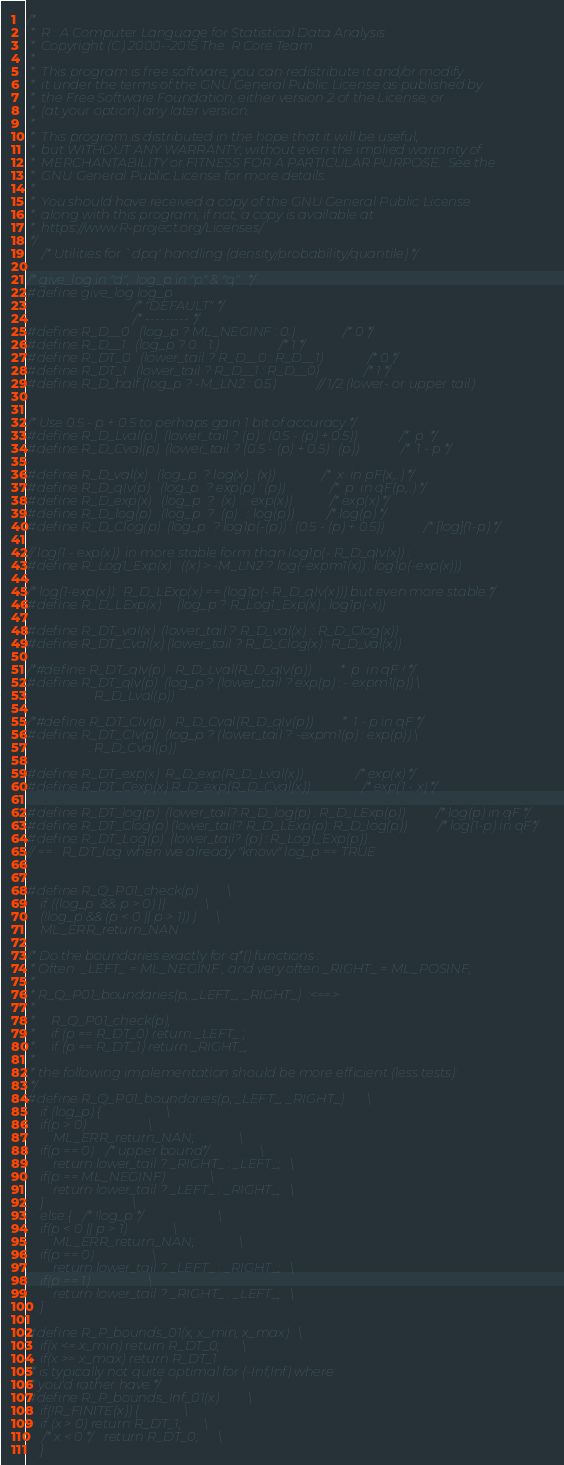<code> <loc_0><loc_0><loc_500><loc_500><_C_>/*
 *  R : A Computer Language for Statistical Data Analysis
 *  Copyright (C) 2000--2015 The  R Core Team
 *
 *  This program is free software; you can redistribute it and/or modify
 *  it under the terms of the GNU General Public License as published by
 *  the Free Software Foundation; either version 2 of the License, or
 *  (at your option) any later version.
 *
 *  This program is distributed in the hope that it will be useful,
 *  but WITHOUT ANY WARRANTY; without even the implied warranty of
 *  MERCHANTABILITY or FITNESS FOR A PARTICULAR PURPOSE.  See the
 *  GNU General Public License for more details.
 *
 *  You should have received a copy of the GNU General Public License
 *  along with this program; if not, a copy is available at
 *  https://www.R-project.org/Licenses/
 */
	/* Utilities for `dpq' handling (density/probability/quantile) */

/* give_log in "d";  log_p in "p" & "q" : */
#define give_log log_p
							/* "DEFAULT" */
							/* --------- */
#define R_D__0	(log_p ? ML_NEGINF : 0.)		/* 0 */
#define R_D__1	(log_p ? 0. : 1.)			/* 1 */
#define R_DT_0	(lower_tail ? R_D__0 : R_D__1)		/* 0 */
#define R_DT_1	(lower_tail ? R_D__1 : R_D__0)		/* 1 */
#define R_D_half (log_p ? -M_LN2 : 0.5)		// 1/2 (lower- or upper tail)


/* Use 0.5 - p + 0.5 to perhaps gain 1 bit of accuracy */
#define R_D_Lval(p)	(lower_tail ? (p) : (0.5 - (p) + 0.5))	/*  p  */
#define R_D_Cval(p)	(lower_tail ? (0.5 - (p) + 0.5) : (p))	/*  1 - p */

#define R_D_val(x)	(log_p	? log(x) : (x))		/*  x  in pF(x,..) */
#define R_D_qIv(p)	(log_p	? exp(p) : (p))		/*  p  in qF(p,..) */
#define R_D_exp(x)	(log_p	?  (x)	 : exp(x))	/* exp(x) */
#define R_D_log(p)	(log_p	?  (p)	 : log(p))	/* log(p) */
#define R_D_Clog(p)	(log_p	? log1p(-(p)) : (0.5 - (p) + 0.5)) /* [log](1-p) */

// log(1 - exp(x))  in more stable form than log1p(- R_D_qIv(x)) :
#define R_Log1_Exp(x)   ((x) > -M_LN2 ? log(-expm1(x)) : log1p(-exp(x)))

/* log(1-exp(x)):  R_D_LExp(x) == (log1p(- R_D_qIv(x))) but even more stable:*/
#define R_D_LExp(x)     (log_p ? R_Log1_Exp(x) : log1p(-x))

#define R_DT_val(x)	(lower_tail ? R_D_val(x)  : R_D_Clog(x))
#define R_DT_Cval(x)	(lower_tail ? R_D_Clog(x) : R_D_val(x))

/*#define R_DT_qIv(p)	R_D_Lval(R_D_qIv(p))		 *  p  in qF ! */
#define R_DT_qIv(p)	(log_p ? (lower_tail ? exp(p) : - expm1(p)) \
			       : R_D_Lval(p))

/*#define R_DT_CIv(p)	R_D_Cval(R_D_qIv(p))		 *  1 - p in qF */
#define R_DT_CIv(p)	(log_p ? (lower_tail ? -expm1(p) : exp(p)) \
			       : R_D_Cval(p))

#define R_DT_exp(x)	R_D_exp(R_D_Lval(x))		/* exp(x) */
#define R_DT_Cexp(x)	R_D_exp(R_D_Cval(x))		/* exp(1 - x) */

#define R_DT_log(p)	(lower_tail? R_D_log(p) : R_D_LExp(p))/* log(p) in qF */
#define R_DT_Clog(p)	(lower_tail? R_D_LExp(p): R_D_log(p))/* log(1-p) in qF*/
#define R_DT_Log(p)	(lower_tail? (p) : R_Log1_Exp(p))
// ==   R_DT_log when we already "know" log_p == TRUE


#define R_Q_P01_check(p)			\
    if ((log_p	&& p > 0) ||			\
	(!log_p && (p < 0 || p > 1)) )		\
	ML_ERR_return_NAN

/* Do the boundaries exactly for q*() functions :
 * Often  _LEFT_ = ML_NEGINF , and very often _RIGHT_ = ML_POSINF;
 *
 * R_Q_P01_boundaries(p, _LEFT_, _RIGHT_)  :<==>
 *
 *     R_Q_P01_check(p);
 *     if (p == R_DT_0) return _LEFT_ ;
 *     if (p == R_DT_1) return _RIGHT_;
 *
 * the following implementation should be more efficient (less tests):
 */
#define R_Q_P01_boundaries(p, _LEFT_, _RIGHT_)		\
    if (log_p) {					\
	if(p > 0)					\
	    ML_ERR_return_NAN;				\
	if(p == 0) /* upper bound*/			\
	    return lower_tail ? _RIGHT_ : _LEFT_;	\
	if(p == ML_NEGINF)				\
	    return lower_tail ? _LEFT_ : _RIGHT_;	\
    }							\
    else { /* !log_p */					\
	if(p < 0 || p > 1)				\
	    ML_ERR_return_NAN;				\
	if(p == 0)					\
	    return lower_tail ? _LEFT_ : _RIGHT_;	\
	if(p == 1)					\
	    return lower_tail ? _RIGHT_ : _LEFT_;	\
    }

#define R_P_bounds_01(x, x_min, x_max)	\
    if(x <= x_min) return R_DT_0;		\
    if(x >= x_max) return R_DT_1
/* is typically not quite optimal for (-Inf,Inf) where
 * you'd rather have */
#define R_P_bounds_Inf_01(x)			\
    if(!R_FINITE(x)) {				\
	if (x > 0) return R_DT_1;		\
	/* x < 0 */return R_DT_0;		\
    }


</code> 